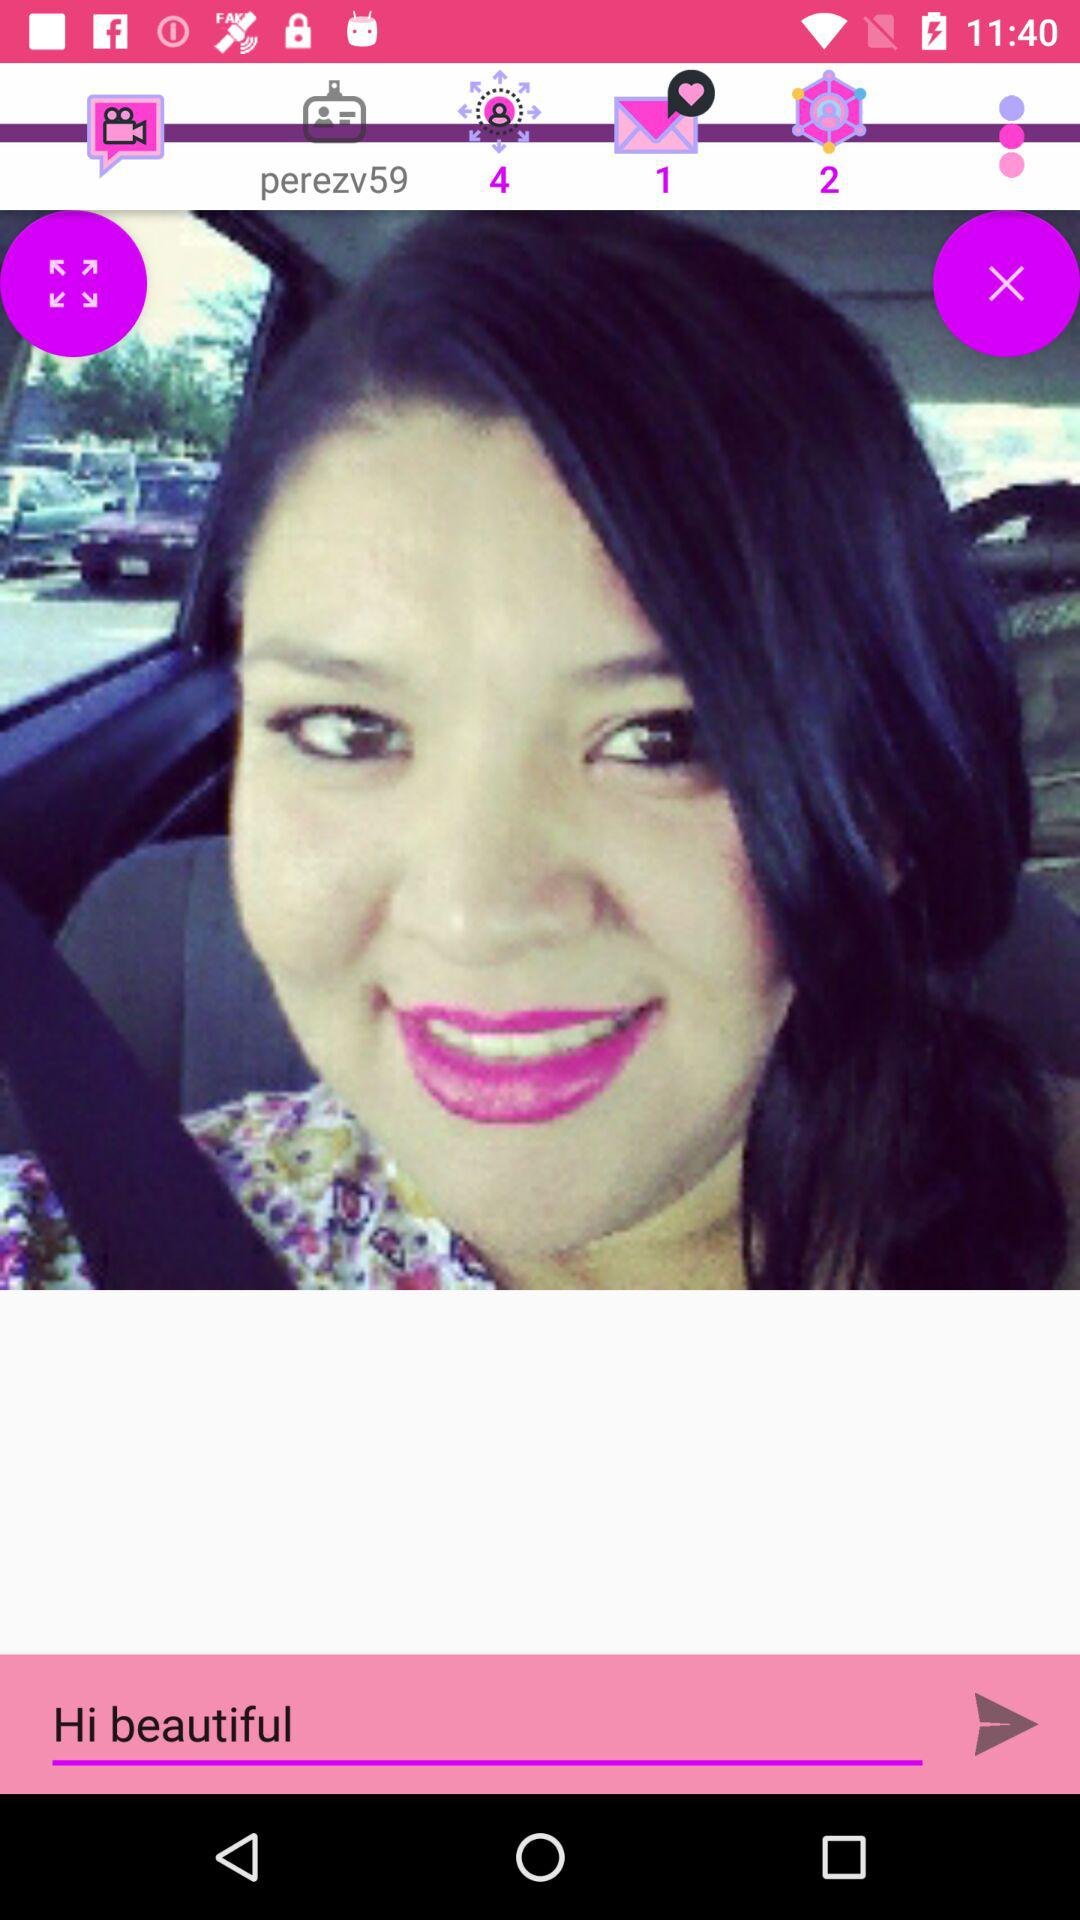How many unread messages are there? There is 1 unread message. 